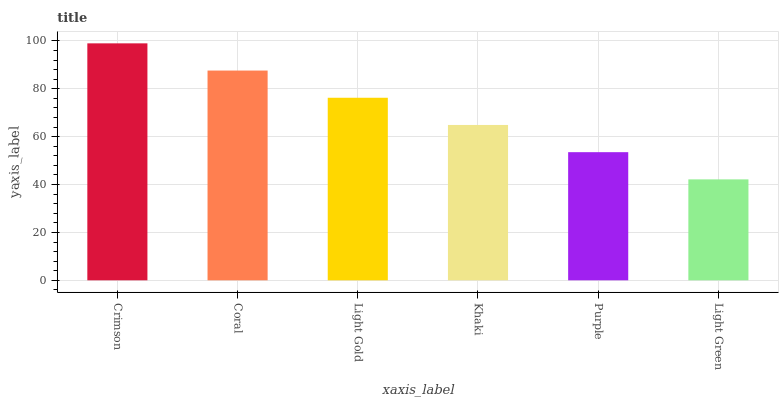Is Light Green the minimum?
Answer yes or no. Yes. Is Crimson the maximum?
Answer yes or no. Yes. Is Coral the minimum?
Answer yes or no. No. Is Coral the maximum?
Answer yes or no. No. Is Crimson greater than Coral?
Answer yes or no. Yes. Is Coral less than Crimson?
Answer yes or no. Yes. Is Coral greater than Crimson?
Answer yes or no. No. Is Crimson less than Coral?
Answer yes or no. No. Is Light Gold the high median?
Answer yes or no. Yes. Is Khaki the low median?
Answer yes or no. Yes. Is Light Green the high median?
Answer yes or no. No. Is Purple the low median?
Answer yes or no. No. 